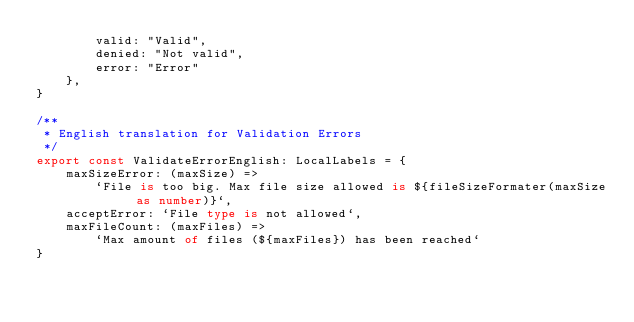<code> <loc_0><loc_0><loc_500><loc_500><_TypeScript_>        valid: "Valid",
        denied: "Not valid",
        error: "Error"
    },
}

/**
 * English translation for Validation Errors
 */
export const ValidateErrorEnglish: LocalLabels = {
    maxSizeError: (maxSize) =>
        `File is too big. Max file size allowed is ${fileSizeFormater(maxSize as number)}`,
    acceptError: `File type is not allowed`,
    maxFileCount: (maxFiles) =>
        `Max amount of files (${maxFiles}) has been reached`
}</code> 